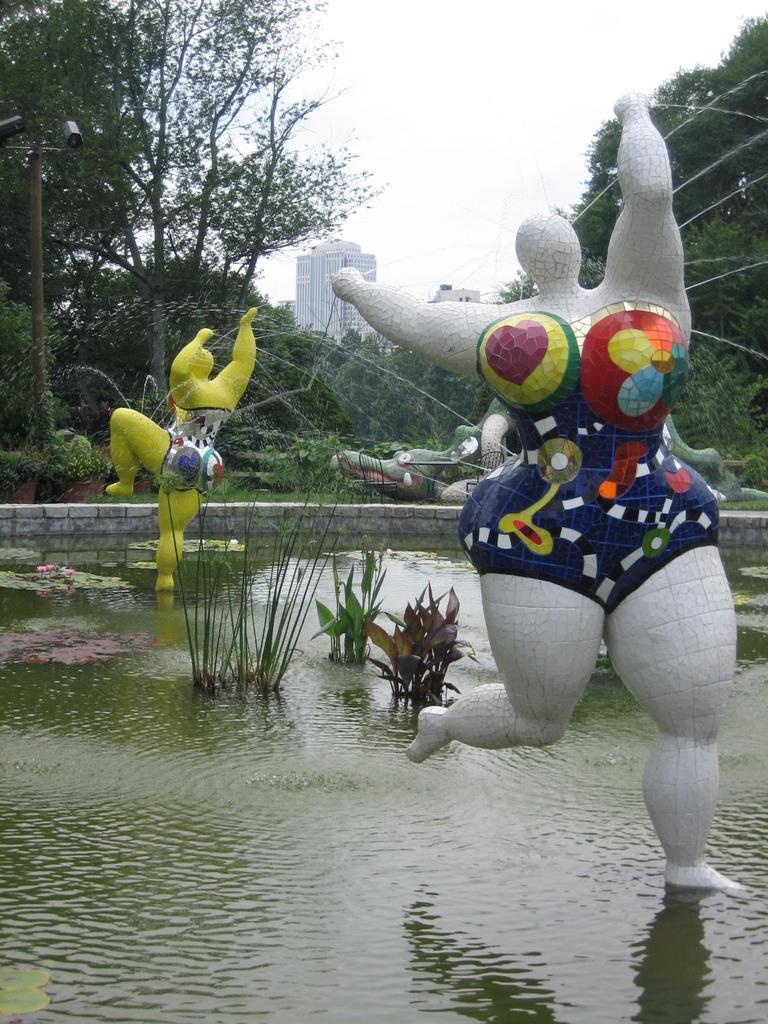Please provide a concise description of this image. In this image we can see the pond statues. Here we can see the water. In the background, we can see the buildings and trees. 